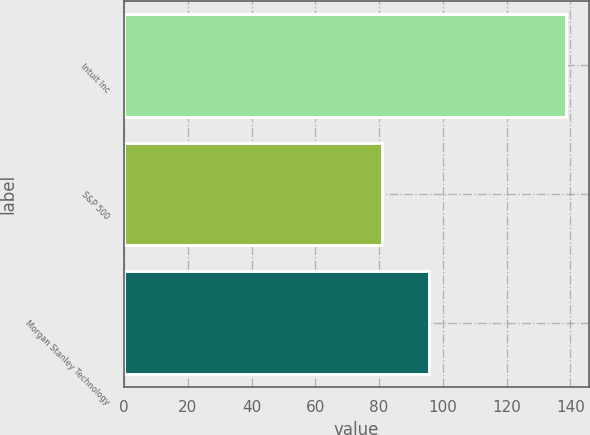Convert chart to OTSL. <chart><loc_0><loc_0><loc_500><loc_500><bar_chart><fcel>Intuit Inc<fcel>S&P 500<fcel>Morgan Stanley Technology<nl><fcel>138.79<fcel>81<fcel>95.7<nl></chart> 